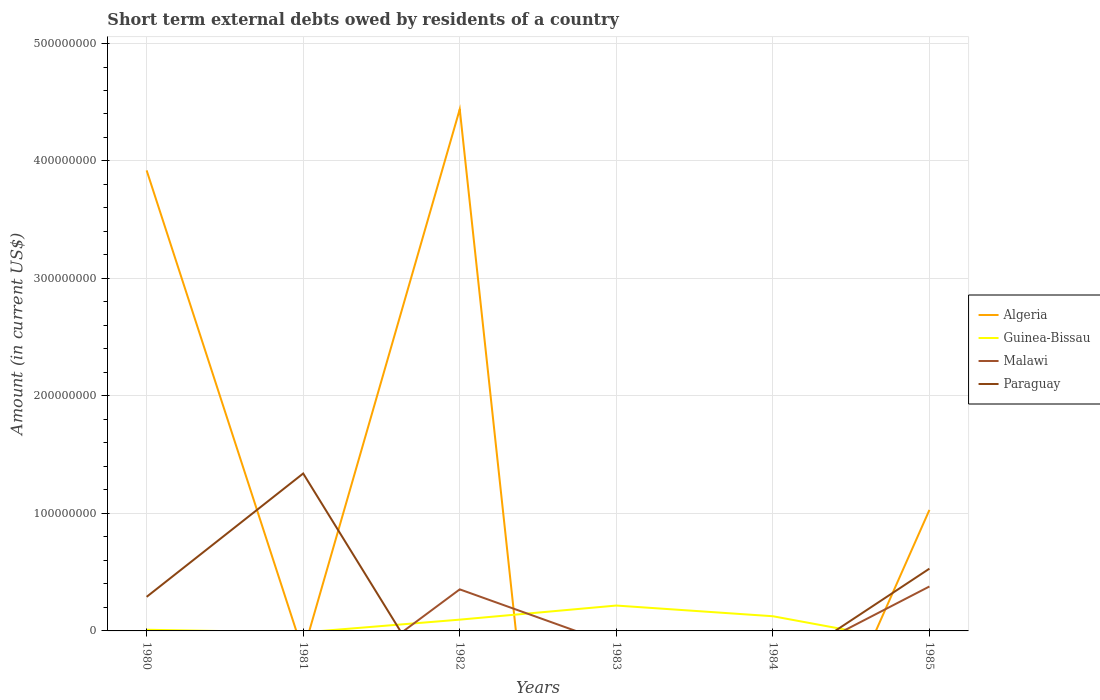How many different coloured lines are there?
Provide a short and direct response. 4. Does the line corresponding to Malawi intersect with the line corresponding to Guinea-Bissau?
Your answer should be compact. Yes. Is the number of lines equal to the number of legend labels?
Offer a very short reply. No. What is the total amount of short-term external debts owed by residents in Guinea-Bissau in the graph?
Ensure brevity in your answer.  -1.20e+07. What is the difference between the highest and the second highest amount of short-term external debts owed by residents in Paraguay?
Offer a terse response. 1.34e+08. Is the amount of short-term external debts owed by residents in Guinea-Bissau strictly greater than the amount of short-term external debts owed by residents in Malawi over the years?
Provide a short and direct response. No. How many lines are there?
Ensure brevity in your answer.  4. What is the difference between two consecutive major ticks on the Y-axis?
Keep it short and to the point. 1.00e+08. Does the graph contain any zero values?
Give a very brief answer. Yes. Does the graph contain grids?
Your answer should be very brief. Yes. What is the title of the graph?
Make the answer very short. Short term external debts owed by residents of a country. Does "Afghanistan" appear as one of the legend labels in the graph?
Your answer should be very brief. No. What is the label or title of the X-axis?
Make the answer very short. Years. What is the Amount (in current US$) of Algeria in 1980?
Give a very brief answer. 3.92e+08. What is the Amount (in current US$) in Guinea-Bissau in 1980?
Offer a terse response. 1.00e+06. What is the Amount (in current US$) in Paraguay in 1980?
Your response must be concise. 2.90e+07. What is the Amount (in current US$) in Malawi in 1981?
Keep it short and to the point. 0. What is the Amount (in current US$) in Paraguay in 1981?
Offer a terse response. 1.34e+08. What is the Amount (in current US$) in Algeria in 1982?
Provide a succinct answer. 4.44e+08. What is the Amount (in current US$) in Guinea-Bissau in 1982?
Give a very brief answer. 9.60e+06. What is the Amount (in current US$) in Malawi in 1982?
Provide a succinct answer. 3.54e+07. What is the Amount (in current US$) in Algeria in 1983?
Give a very brief answer. 0. What is the Amount (in current US$) of Guinea-Bissau in 1983?
Provide a short and direct response. 2.16e+07. What is the Amount (in current US$) in Malawi in 1983?
Offer a very short reply. 0. What is the Amount (in current US$) of Paraguay in 1983?
Your answer should be very brief. 0. What is the Amount (in current US$) in Guinea-Bissau in 1984?
Your answer should be compact. 1.25e+07. What is the Amount (in current US$) of Algeria in 1985?
Give a very brief answer. 1.03e+08. What is the Amount (in current US$) in Guinea-Bissau in 1985?
Make the answer very short. 0. What is the Amount (in current US$) in Malawi in 1985?
Ensure brevity in your answer.  3.78e+07. What is the Amount (in current US$) in Paraguay in 1985?
Offer a very short reply. 5.30e+07. Across all years, what is the maximum Amount (in current US$) in Algeria?
Keep it short and to the point. 4.44e+08. Across all years, what is the maximum Amount (in current US$) of Guinea-Bissau?
Ensure brevity in your answer.  2.16e+07. Across all years, what is the maximum Amount (in current US$) of Malawi?
Your response must be concise. 3.78e+07. Across all years, what is the maximum Amount (in current US$) of Paraguay?
Keep it short and to the point. 1.34e+08. Across all years, what is the minimum Amount (in current US$) in Paraguay?
Make the answer very short. 0. What is the total Amount (in current US$) in Algeria in the graph?
Give a very brief answer. 9.39e+08. What is the total Amount (in current US$) in Guinea-Bissau in the graph?
Offer a very short reply. 4.47e+07. What is the total Amount (in current US$) in Malawi in the graph?
Offer a very short reply. 7.32e+07. What is the total Amount (in current US$) in Paraguay in the graph?
Ensure brevity in your answer.  2.16e+08. What is the difference between the Amount (in current US$) of Paraguay in 1980 and that in 1981?
Offer a terse response. -1.05e+08. What is the difference between the Amount (in current US$) in Algeria in 1980 and that in 1982?
Keep it short and to the point. -5.20e+07. What is the difference between the Amount (in current US$) in Guinea-Bissau in 1980 and that in 1982?
Provide a succinct answer. -8.60e+06. What is the difference between the Amount (in current US$) in Guinea-Bissau in 1980 and that in 1983?
Keep it short and to the point. -2.06e+07. What is the difference between the Amount (in current US$) in Guinea-Bissau in 1980 and that in 1984?
Give a very brief answer. -1.15e+07. What is the difference between the Amount (in current US$) of Algeria in 1980 and that in 1985?
Your response must be concise. 2.89e+08. What is the difference between the Amount (in current US$) of Paraguay in 1980 and that in 1985?
Offer a terse response. -2.40e+07. What is the difference between the Amount (in current US$) of Paraguay in 1981 and that in 1985?
Provide a short and direct response. 8.10e+07. What is the difference between the Amount (in current US$) in Guinea-Bissau in 1982 and that in 1983?
Your answer should be very brief. -1.20e+07. What is the difference between the Amount (in current US$) of Guinea-Bissau in 1982 and that in 1984?
Offer a very short reply. -2.90e+06. What is the difference between the Amount (in current US$) of Algeria in 1982 and that in 1985?
Your response must be concise. 3.41e+08. What is the difference between the Amount (in current US$) in Malawi in 1982 and that in 1985?
Make the answer very short. -2.44e+06. What is the difference between the Amount (in current US$) in Guinea-Bissau in 1983 and that in 1984?
Your answer should be very brief. 9.10e+06. What is the difference between the Amount (in current US$) in Algeria in 1980 and the Amount (in current US$) in Paraguay in 1981?
Make the answer very short. 2.58e+08. What is the difference between the Amount (in current US$) of Guinea-Bissau in 1980 and the Amount (in current US$) of Paraguay in 1981?
Offer a very short reply. -1.33e+08. What is the difference between the Amount (in current US$) of Algeria in 1980 and the Amount (in current US$) of Guinea-Bissau in 1982?
Ensure brevity in your answer.  3.82e+08. What is the difference between the Amount (in current US$) of Algeria in 1980 and the Amount (in current US$) of Malawi in 1982?
Offer a very short reply. 3.57e+08. What is the difference between the Amount (in current US$) of Guinea-Bissau in 1980 and the Amount (in current US$) of Malawi in 1982?
Give a very brief answer. -3.44e+07. What is the difference between the Amount (in current US$) in Algeria in 1980 and the Amount (in current US$) in Guinea-Bissau in 1983?
Make the answer very short. 3.70e+08. What is the difference between the Amount (in current US$) in Algeria in 1980 and the Amount (in current US$) in Guinea-Bissau in 1984?
Offer a terse response. 3.80e+08. What is the difference between the Amount (in current US$) of Algeria in 1980 and the Amount (in current US$) of Malawi in 1985?
Offer a very short reply. 3.54e+08. What is the difference between the Amount (in current US$) of Algeria in 1980 and the Amount (in current US$) of Paraguay in 1985?
Offer a terse response. 3.39e+08. What is the difference between the Amount (in current US$) of Guinea-Bissau in 1980 and the Amount (in current US$) of Malawi in 1985?
Your answer should be compact. -3.68e+07. What is the difference between the Amount (in current US$) in Guinea-Bissau in 1980 and the Amount (in current US$) in Paraguay in 1985?
Offer a very short reply. -5.20e+07. What is the difference between the Amount (in current US$) in Algeria in 1982 and the Amount (in current US$) in Guinea-Bissau in 1983?
Your response must be concise. 4.22e+08. What is the difference between the Amount (in current US$) of Algeria in 1982 and the Amount (in current US$) of Guinea-Bissau in 1984?
Keep it short and to the point. 4.32e+08. What is the difference between the Amount (in current US$) in Algeria in 1982 and the Amount (in current US$) in Malawi in 1985?
Your answer should be compact. 4.06e+08. What is the difference between the Amount (in current US$) in Algeria in 1982 and the Amount (in current US$) in Paraguay in 1985?
Keep it short and to the point. 3.91e+08. What is the difference between the Amount (in current US$) in Guinea-Bissau in 1982 and the Amount (in current US$) in Malawi in 1985?
Give a very brief answer. -2.82e+07. What is the difference between the Amount (in current US$) in Guinea-Bissau in 1982 and the Amount (in current US$) in Paraguay in 1985?
Your answer should be compact. -4.34e+07. What is the difference between the Amount (in current US$) in Malawi in 1982 and the Amount (in current US$) in Paraguay in 1985?
Provide a succinct answer. -1.76e+07. What is the difference between the Amount (in current US$) of Guinea-Bissau in 1983 and the Amount (in current US$) of Malawi in 1985?
Offer a terse response. -1.62e+07. What is the difference between the Amount (in current US$) in Guinea-Bissau in 1983 and the Amount (in current US$) in Paraguay in 1985?
Offer a very short reply. -3.14e+07. What is the difference between the Amount (in current US$) of Guinea-Bissau in 1984 and the Amount (in current US$) of Malawi in 1985?
Keep it short and to the point. -2.53e+07. What is the difference between the Amount (in current US$) of Guinea-Bissau in 1984 and the Amount (in current US$) of Paraguay in 1985?
Make the answer very short. -4.05e+07. What is the average Amount (in current US$) in Algeria per year?
Make the answer very short. 1.56e+08. What is the average Amount (in current US$) of Guinea-Bissau per year?
Your answer should be very brief. 7.45e+06. What is the average Amount (in current US$) of Malawi per year?
Give a very brief answer. 1.22e+07. What is the average Amount (in current US$) of Paraguay per year?
Give a very brief answer. 3.60e+07. In the year 1980, what is the difference between the Amount (in current US$) in Algeria and Amount (in current US$) in Guinea-Bissau?
Provide a succinct answer. 3.91e+08. In the year 1980, what is the difference between the Amount (in current US$) of Algeria and Amount (in current US$) of Paraguay?
Provide a succinct answer. 3.63e+08. In the year 1980, what is the difference between the Amount (in current US$) of Guinea-Bissau and Amount (in current US$) of Paraguay?
Your response must be concise. -2.80e+07. In the year 1982, what is the difference between the Amount (in current US$) of Algeria and Amount (in current US$) of Guinea-Bissau?
Provide a succinct answer. 4.34e+08. In the year 1982, what is the difference between the Amount (in current US$) in Algeria and Amount (in current US$) in Malawi?
Ensure brevity in your answer.  4.09e+08. In the year 1982, what is the difference between the Amount (in current US$) of Guinea-Bissau and Amount (in current US$) of Malawi?
Your answer should be compact. -2.58e+07. In the year 1985, what is the difference between the Amount (in current US$) of Algeria and Amount (in current US$) of Malawi?
Your answer should be compact. 6.52e+07. In the year 1985, what is the difference between the Amount (in current US$) of Malawi and Amount (in current US$) of Paraguay?
Ensure brevity in your answer.  -1.52e+07. What is the ratio of the Amount (in current US$) in Paraguay in 1980 to that in 1981?
Your answer should be very brief. 0.22. What is the ratio of the Amount (in current US$) in Algeria in 1980 to that in 1982?
Make the answer very short. 0.88. What is the ratio of the Amount (in current US$) in Guinea-Bissau in 1980 to that in 1982?
Provide a succinct answer. 0.1. What is the ratio of the Amount (in current US$) of Guinea-Bissau in 1980 to that in 1983?
Offer a terse response. 0.05. What is the ratio of the Amount (in current US$) in Guinea-Bissau in 1980 to that in 1984?
Your response must be concise. 0.08. What is the ratio of the Amount (in current US$) in Algeria in 1980 to that in 1985?
Ensure brevity in your answer.  3.81. What is the ratio of the Amount (in current US$) in Paraguay in 1980 to that in 1985?
Give a very brief answer. 0.55. What is the ratio of the Amount (in current US$) of Paraguay in 1981 to that in 1985?
Your answer should be compact. 2.53. What is the ratio of the Amount (in current US$) of Guinea-Bissau in 1982 to that in 1983?
Give a very brief answer. 0.44. What is the ratio of the Amount (in current US$) of Guinea-Bissau in 1982 to that in 1984?
Provide a succinct answer. 0.77. What is the ratio of the Amount (in current US$) of Algeria in 1982 to that in 1985?
Your answer should be compact. 4.31. What is the ratio of the Amount (in current US$) in Malawi in 1982 to that in 1985?
Provide a succinct answer. 0.94. What is the ratio of the Amount (in current US$) in Guinea-Bissau in 1983 to that in 1984?
Offer a very short reply. 1.73. What is the difference between the highest and the second highest Amount (in current US$) in Algeria?
Your answer should be very brief. 5.20e+07. What is the difference between the highest and the second highest Amount (in current US$) of Guinea-Bissau?
Provide a succinct answer. 9.10e+06. What is the difference between the highest and the second highest Amount (in current US$) in Paraguay?
Make the answer very short. 8.10e+07. What is the difference between the highest and the lowest Amount (in current US$) of Algeria?
Provide a short and direct response. 4.44e+08. What is the difference between the highest and the lowest Amount (in current US$) in Guinea-Bissau?
Offer a terse response. 2.16e+07. What is the difference between the highest and the lowest Amount (in current US$) of Malawi?
Give a very brief answer. 3.78e+07. What is the difference between the highest and the lowest Amount (in current US$) in Paraguay?
Your answer should be compact. 1.34e+08. 